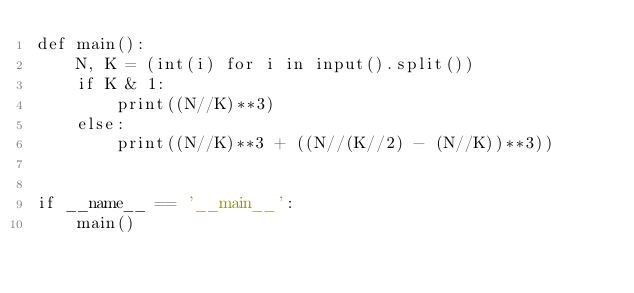<code> <loc_0><loc_0><loc_500><loc_500><_Python_>def main():
    N, K = (int(i) for i in input().split())
    if K & 1:
        print((N//K)**3)
    else:
        print((N//K)**3 + ((N//(K//2) - (N//K))**3))


if __name__ == '__main__':
    main()
</code> 